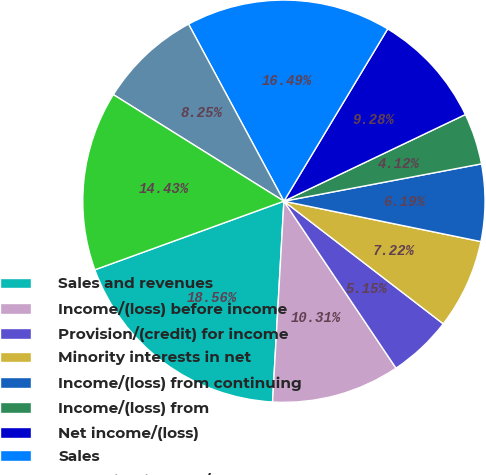Convert chart to OTSL. <chart><loc_0><loc_0><loc_500><loc_500><pie_chart><fcel>Sales and revenues<fcel>Income/(loss) before income<fcel>Provision/(credit) for income<fcel>Minority interests in net<fcel>Income/(loss) from continuing<fcel>Income/(loss) from<fcel>Net income/(loss)<fcel>Sales<fcel>Operating income/(loss)<fcel>Revenues<nl><fcel>18.56%<fcel>10.31%<fcel>5.15%<fcel>7.22%<fcel>6.19%<fcel>4.12%<fcel>9.28%<fcel>16.49%<fcel>8.25%<fcel>14.43%<nl></chart> 